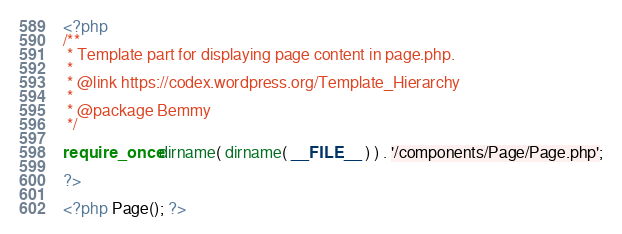Convert code to text. <code><loc_0><loc_0><loc_500><loc_500><_PHP_><?php
/**
 * Template part for displaying page content in page.php.
 *
 * @link https://codex.wordpress.org/Template_Hierarchy
 *
 * @package Bemmy
 */

require_once dirname( dirname( __FILE__ ) ) . '/components/Page/Page.php';

?>

<?php Page(); ?>
</code> 